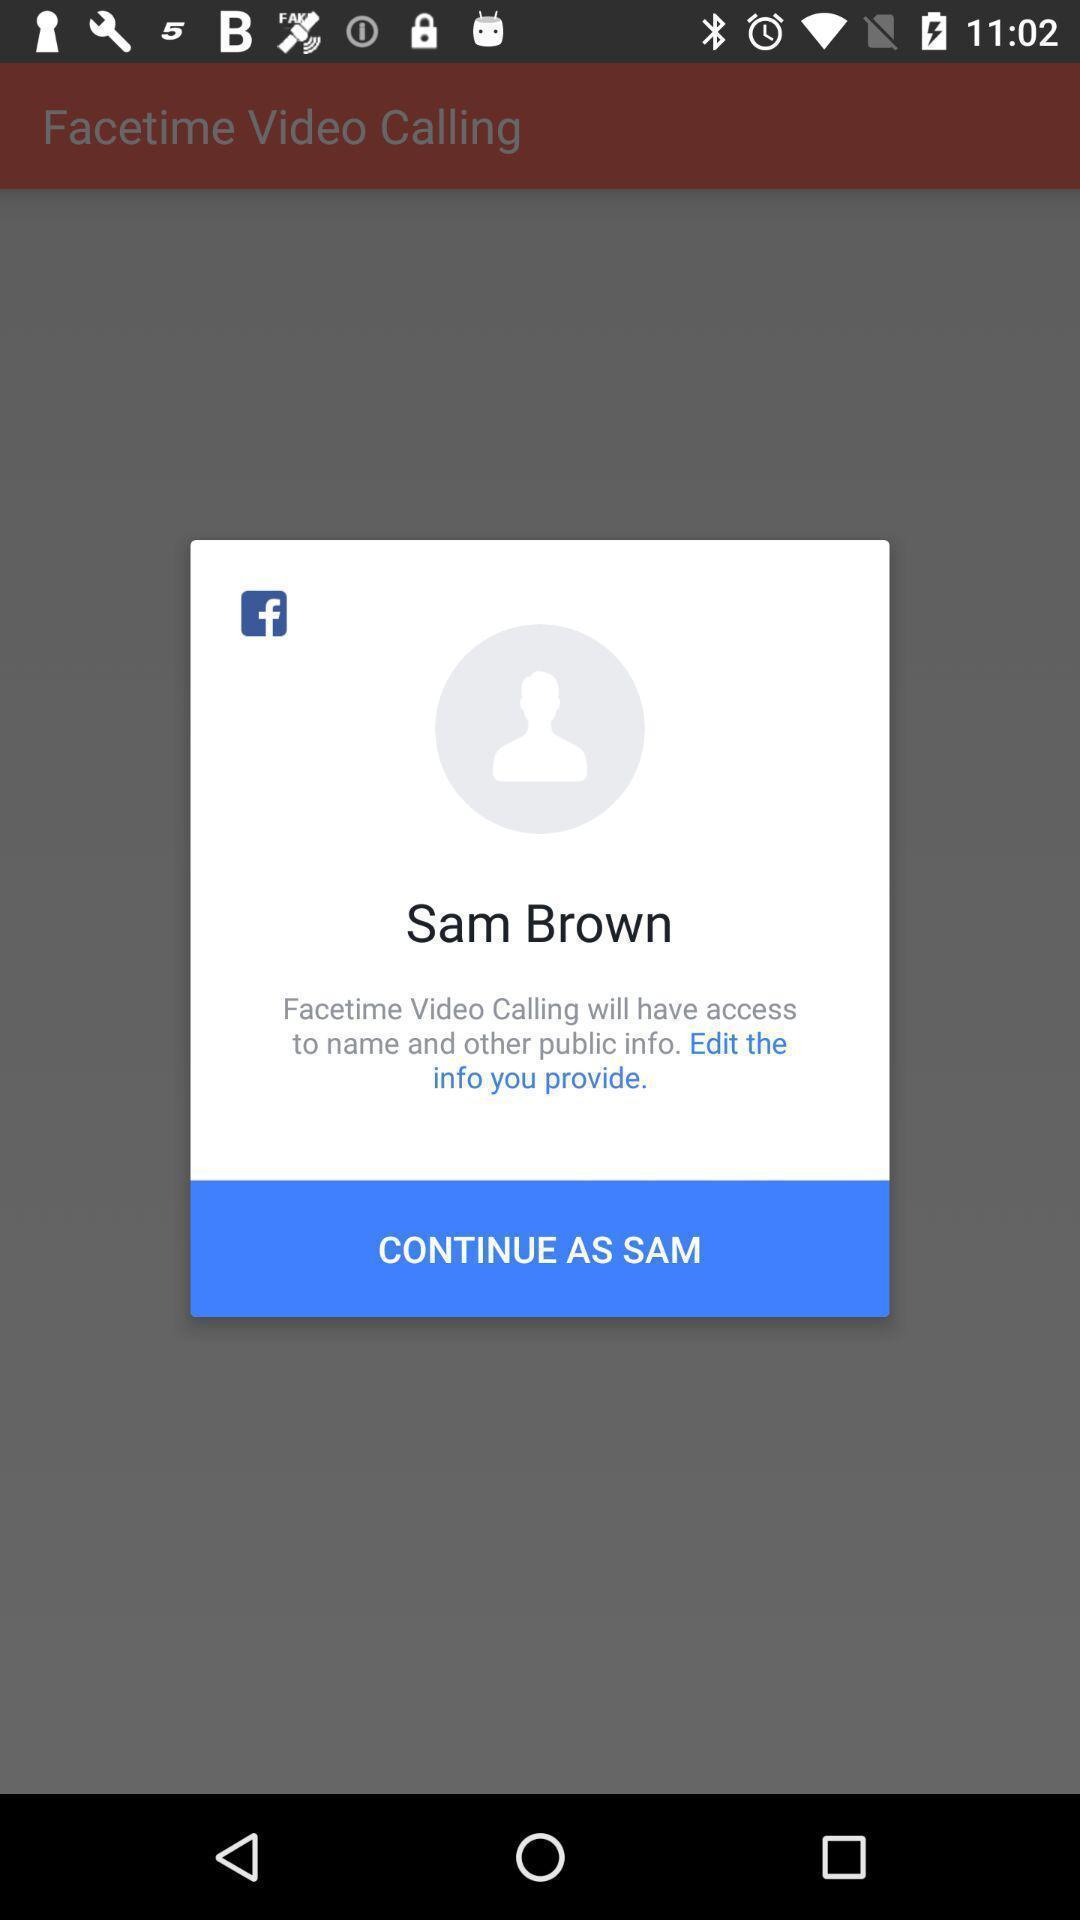Tell me about the visual elements in this screen capture. Pop-up showing social app icon and continue as sam. 